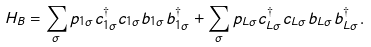Convert formula to latex. <formula><loc_0><loc_0><loc_500><loc_500>H _ { B } = \sum _ { \sigma } p _ { 1 \sigma } c _ { 1 \sigma } ^ { \dagger } c _ { 1 \sigma } b _ { 1 \sigma } b _ { 1 \sigma } ^ { \dagger } + \sum _ { \sigma } p _ { L \sigma } c _ { L \sigma } ^ { \dagger } c _ { L \sigma } b _ { L \sigma } b _ { L \sigma } ^ { \dagger } .</formula> 